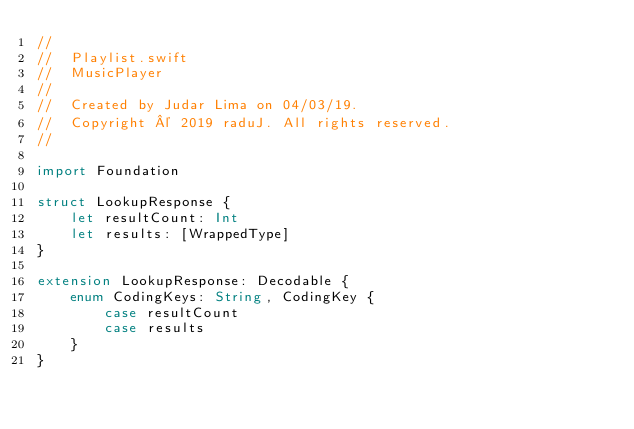Convert code to text. <code><loc_0><loc_0><loc_500><loc_500><_Swift_>//
//  Playlist.swift
//  MusicPlayer
//
//  Created by Judar Lima on 04/03/19.
//  Copyright © 2019 raduJ. All rights reserved.
//

import Foundation

struct LookupResponse {
    let resultCount: Int
    let results: [WrappedType]
}

extension LookupResponse: Decodable {
    enum CodingKeys: String, CodingKey {
        case resultCount
        case results
    }    
}
</code> 